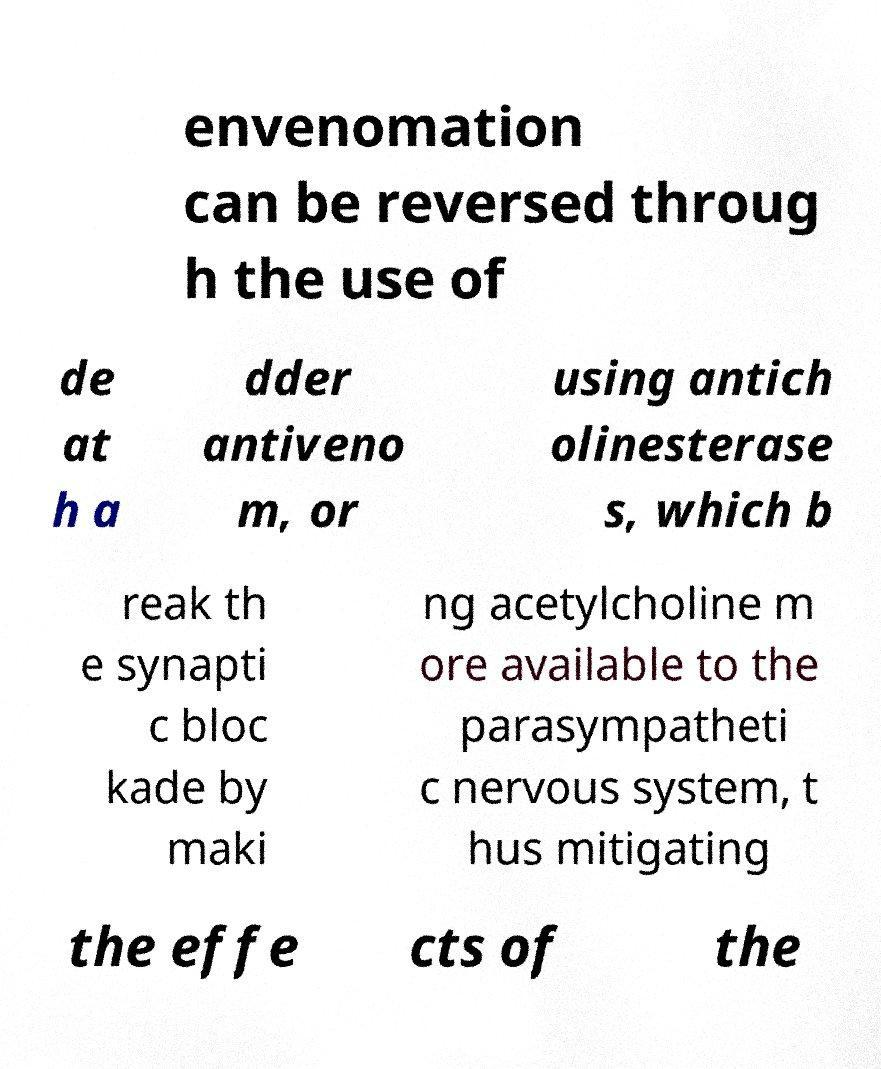Could you assist in decoding the text presented in this image and type it out clearly? envenomation can be reversed throug h the use of de at h a dder antiveno m, or using antich olinesterase s, which b reak th e synapti c bloc kade by maki ng acetylcholine m ore available to the parasympatheti c nervous system, t hus mitigating the effe cts of the 